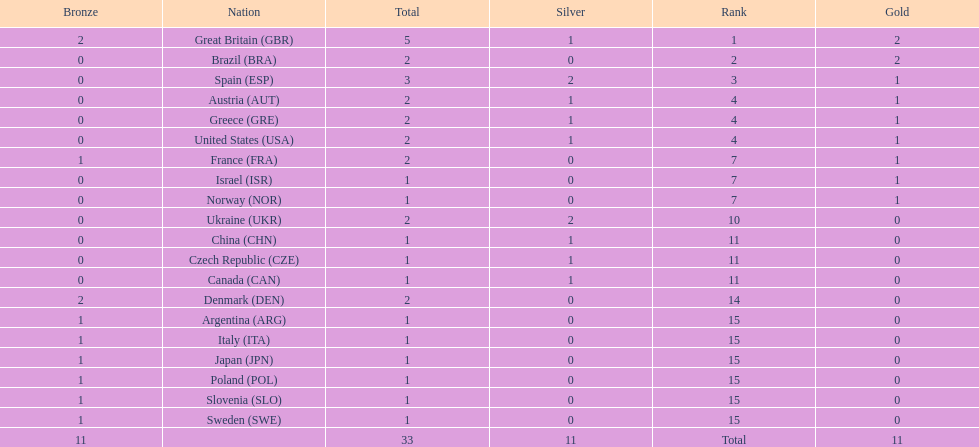Can you parse all the data within this table? {'header': ['Bronze', 'Nation', 'Total', 'Silver', 'Rank', 'Gold'], 'rows': [['2', 'Great Britain\xa0(GBR)', '5', '1', '1', '2'], ['0', 'Brazil\xa0(BRA)', '2', '0', '2', '2'], ['0', 'Spain\xa0(ESP)', '3', '2', '3', '1'], ['0', 'Austria\xa0(AUT)', '2', '1', '4', '1'], ['0', 'Greece\xa0(GRE)', '2', '1', '4', '1'], ['0', 'United States\xa0(USA)', '2', '1', '4', '1'], ['1', 'France\xa0(FRA)', '2', '0', '7', '1'], ['0', 'Israel\xa0(ISR)', '1', '0', '7', '1'], ['0', 'Norway\xa0(NOR)', '1', '0', '7', '1'], ['0', 'Ukraine\xa0(UKR)', '2', '2', '10', '0'], ['0', 'China\xa0(CHN)', '1', '1', '11', '0'], ['0', 'Czech Republic\xa0(CZE)', '1', '1', '11', '0'], ['0', 'Canada\xa0(CAN)', '1', '1', '11', '0'], ['2', 'Denmark\xa0(DEN)', '2', '0', '14', '0'], ['1', 'Argentina\xa0(ARG)', '1', '0', '15', '0'], ['1', 'Italy\xa0(ITA)', '1', '0', '15', '0'], ['1', 'Japan\xa0(JPN)', '1', '0', '15', '0'], ['1', 'Poland\xa0(POL)', '1', '0', '15', '0'], ['1', 'Slovenia\xa0(SLO)', '1', '0', '15', '0'], ['1', 'Sweden\xa0(SWE)', '1', '0', '15', '0'], ['11', '', '33', '11', 'Total', '11']]} In terms of total medals, which nation ranked beside great britain? Spain. 